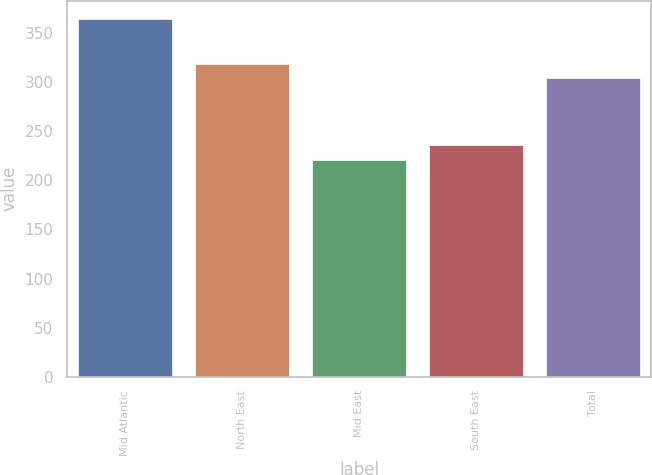Convert chart to OTSL. <chart><loc_0><loc_0><loc_500><loc_500><bar_chart><fcel>Mid Atlantic<fcel>North East<fcel>Mid East<fcel>South East<fcel>Total<nl><fcel>365.1<fcel>318.38<fcel>221.3<fcel>235.68<fcel>304<nl></chart> 